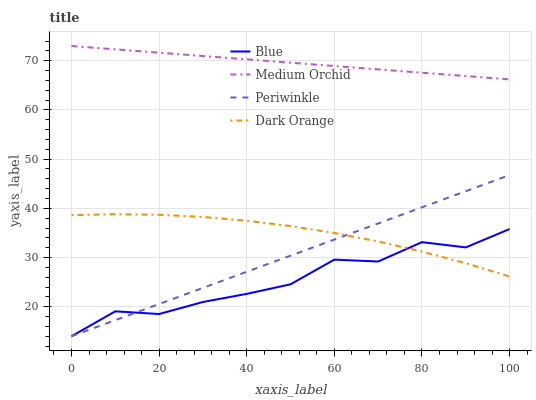Does Blue have the minimum area under the curve?
Answer yes or no. Yes. Does Medium Orchid have the maximum area under the curve?
Answer yes or no. Yes. Does Dark Orange have the minimum area under the curve?
Answer yes or no. No. Does Dark Orange have the maximum area under the curve?
Answer yes or no. No. Is Periwinkle the smoothest?
Answer yes or no. Yes. Is Blue the roughest?
Answer yes or no. Yes. Is Dark Orange the smoothest?
Answer yes or no. No. Is Dark Orange the roughest?
Answer yes or no. No. Does Blue have the lowest value?
Answer yes or no. Yes. Does Dark Orange have the lowest value?
Answer yes or no. No. Does Medium Orchid have the highest value?
Answer yes or no. Yes. Does Dark Orange have the highest value?
Answer yes or no. No. Is Periwinkle less than Medium Orchid?
Answer yes or no. Yes. Is Medium Orchid greater than Blue?
Answer yes or no. Yes. Does Dark Orange intersect Blue?
Answer yes or no. Yes. Is Dark Orange less than Blue?
Answer yes or no. No. Is Dark Orange greater than Blue?
Answer yes or no. No. Does Periwinkle intersect Medium Orchid?
Answer yes or no. No. 